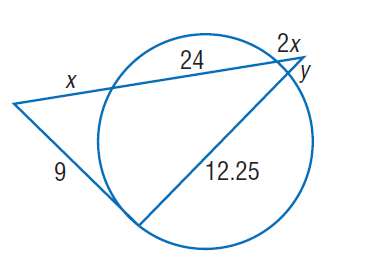Answer the mathemtical geometry problem and directly provide the correct option letter.
Question: Find y. Round to the nearest tenth, if necessary.
Choices: A: 8.6 B: 9 C: 12.25 D: 24 A 